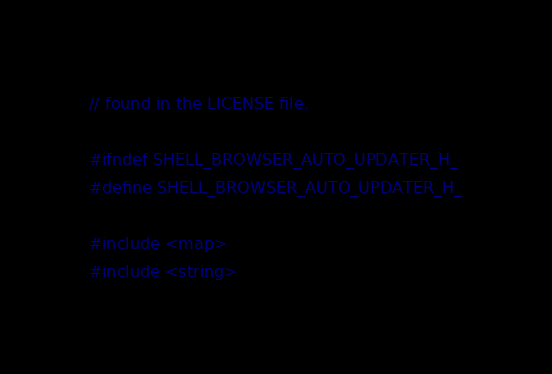<code> <loc_0><loc_0><loc_500><loc_500><_C_>// found in the LICENSE file.

#ifndef SHELL_BROWSER_AUTO_UPDATER_H_
#define SHELL_BROWSER_AUTO_UPDATER_H_

#include <map>
#include <string>
</code> 